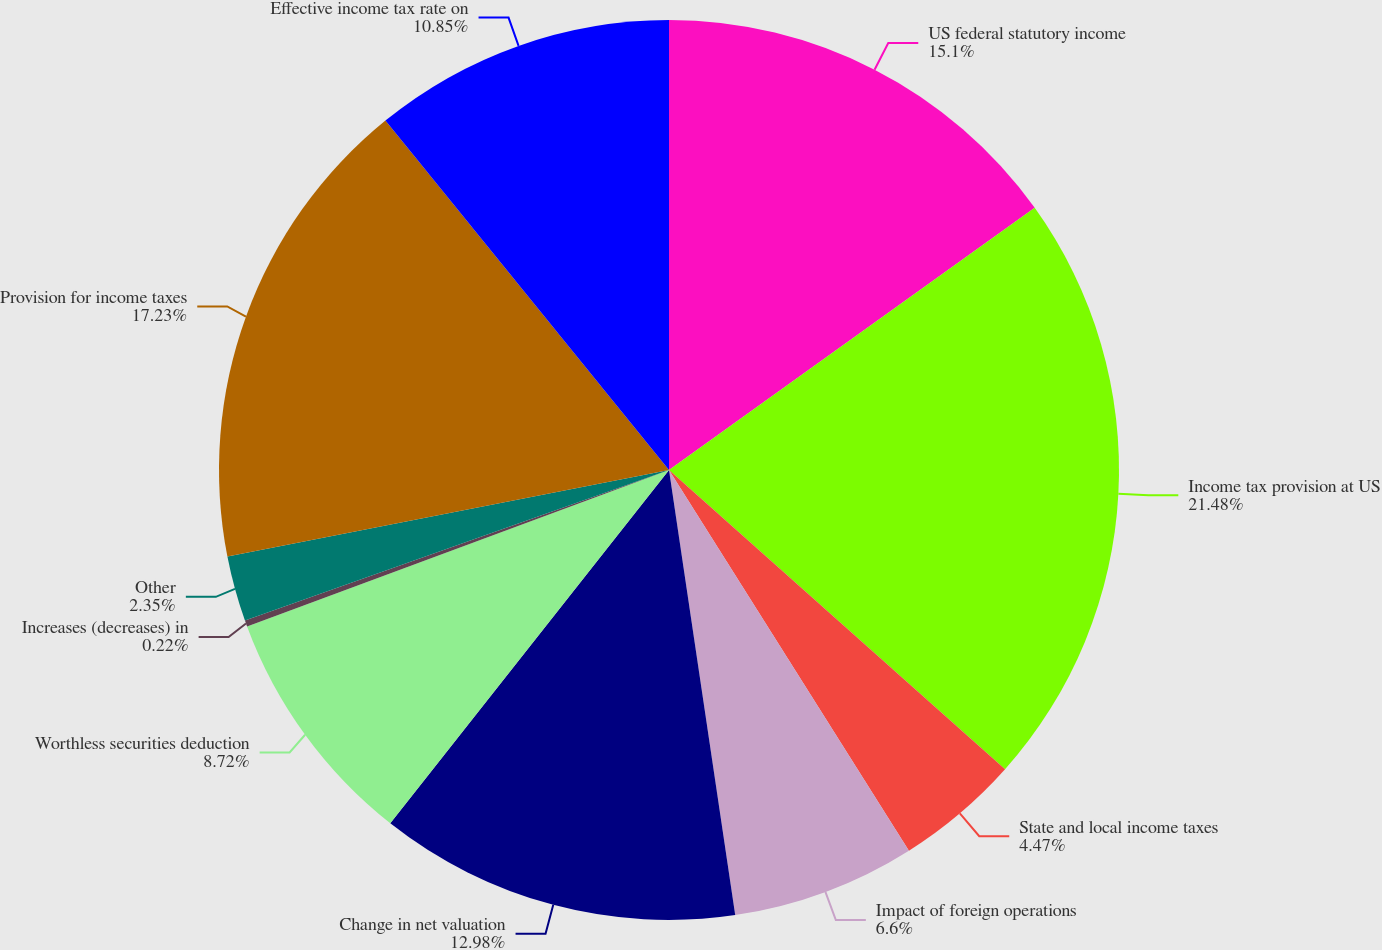<chart> <loc_0><loc_0><loc_500><loc_500><pie_chart><fcel>US federal statutory income<fcel>Income tax provision at US<fcel>State and local income taxes<fcel>Impact of foreign operations<fcel>Change in net valuation<fcel>Worthless securities deduction<fcel>Increases (decreases) in<fcel>Other<fcel>Provision for income taxes<fcel>Effective income tax rate on<nl><fcel>15.1%<fcel>21.48%<fcel>4.47%<fcel>6.6%<fcel>12.98%<fcel>8.72%<fcel>0.22%<fcel>2.35%<fcel>17.23%<fcel>10.85%<nl></chart> 